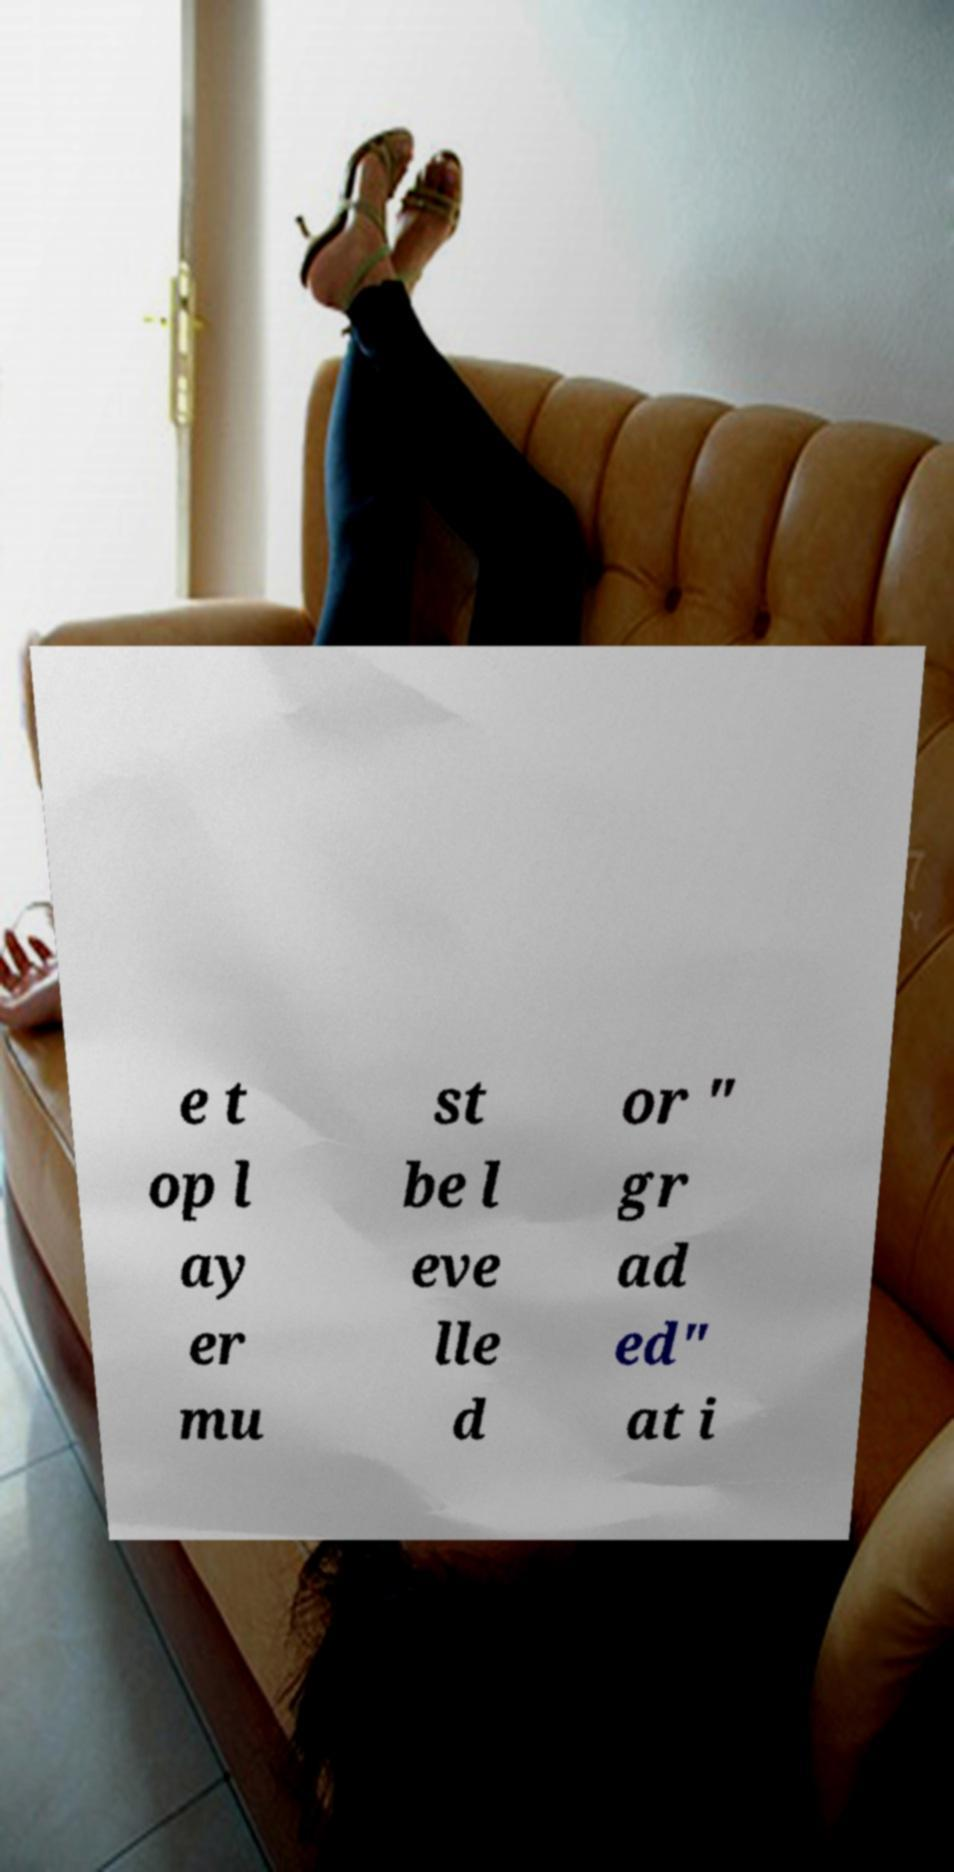Can you read and provide the text displayed in the image?This photo seems to have some interesting text. Can you extract and type it out for me? e t op l ay er mu st be l eve lle d or " gr ad ed" at i 